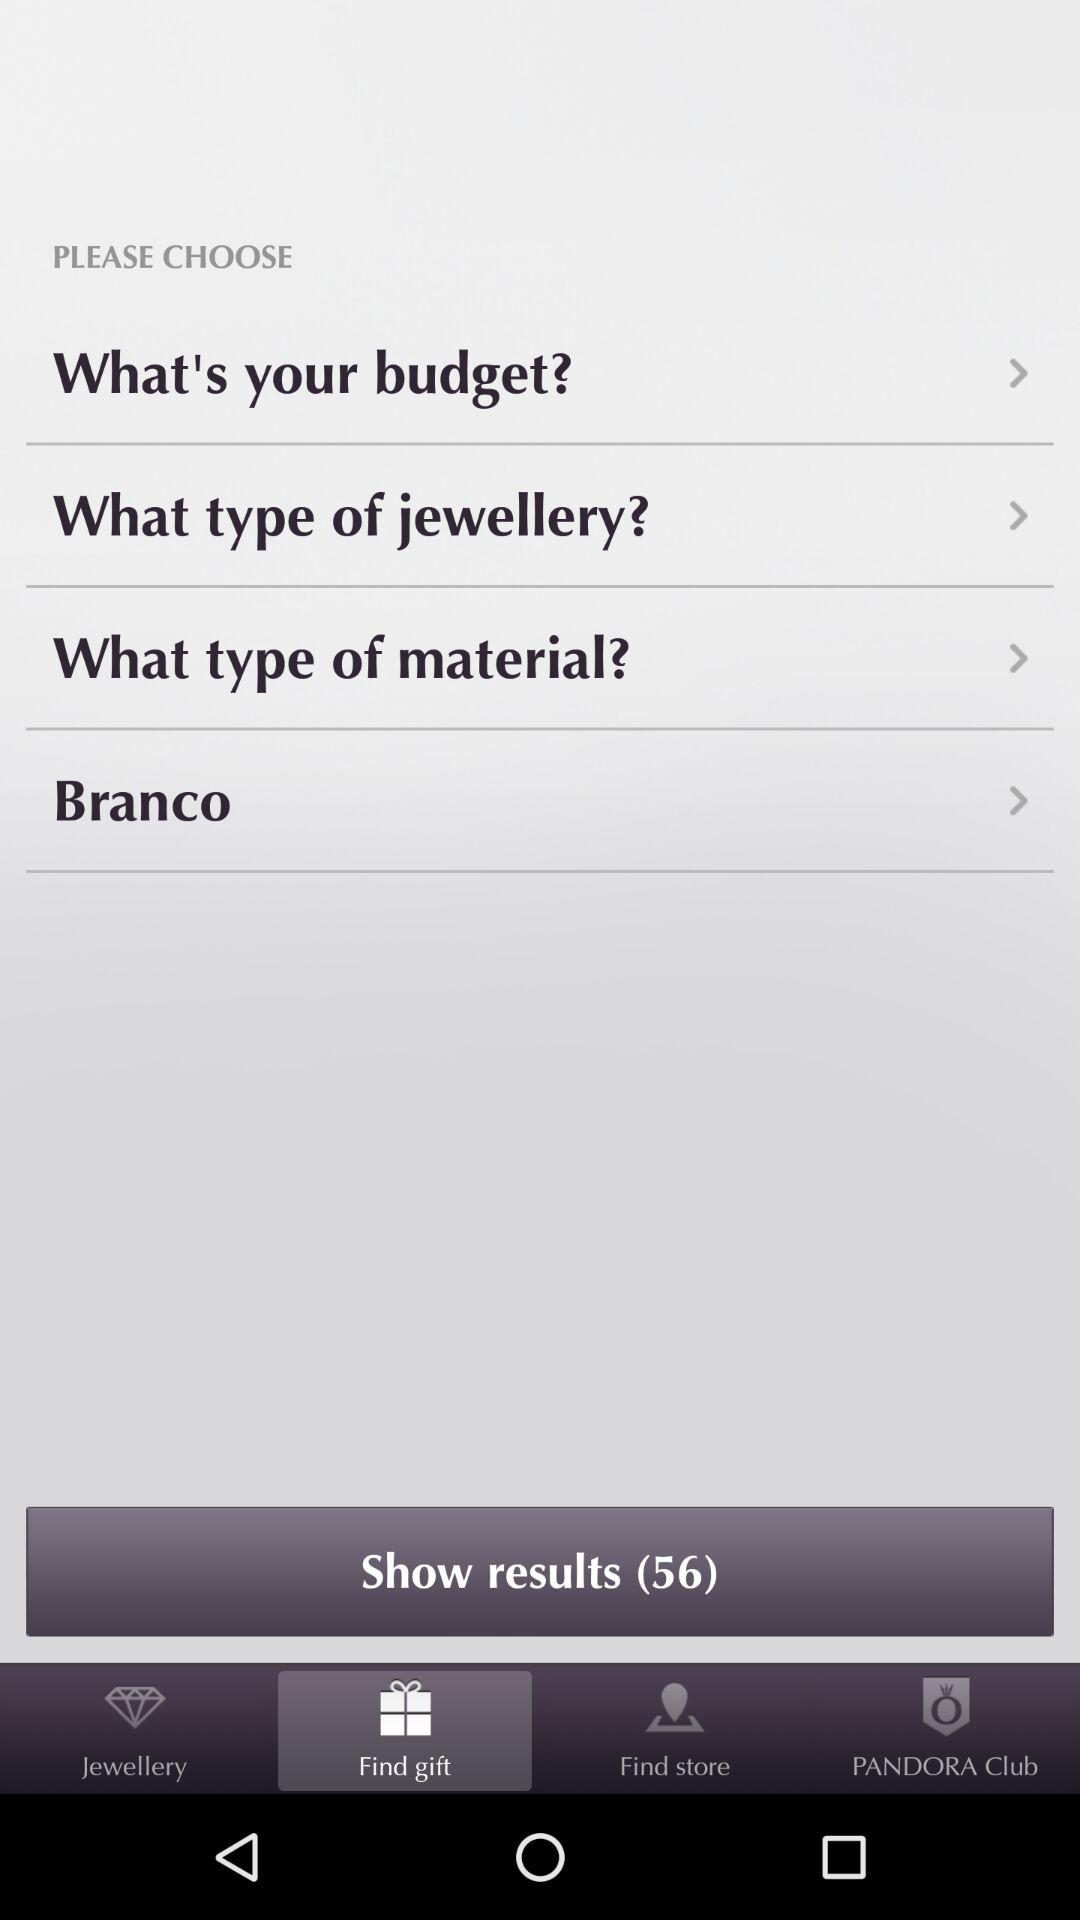Which tab is selected? The selected tab is "Find gift". 